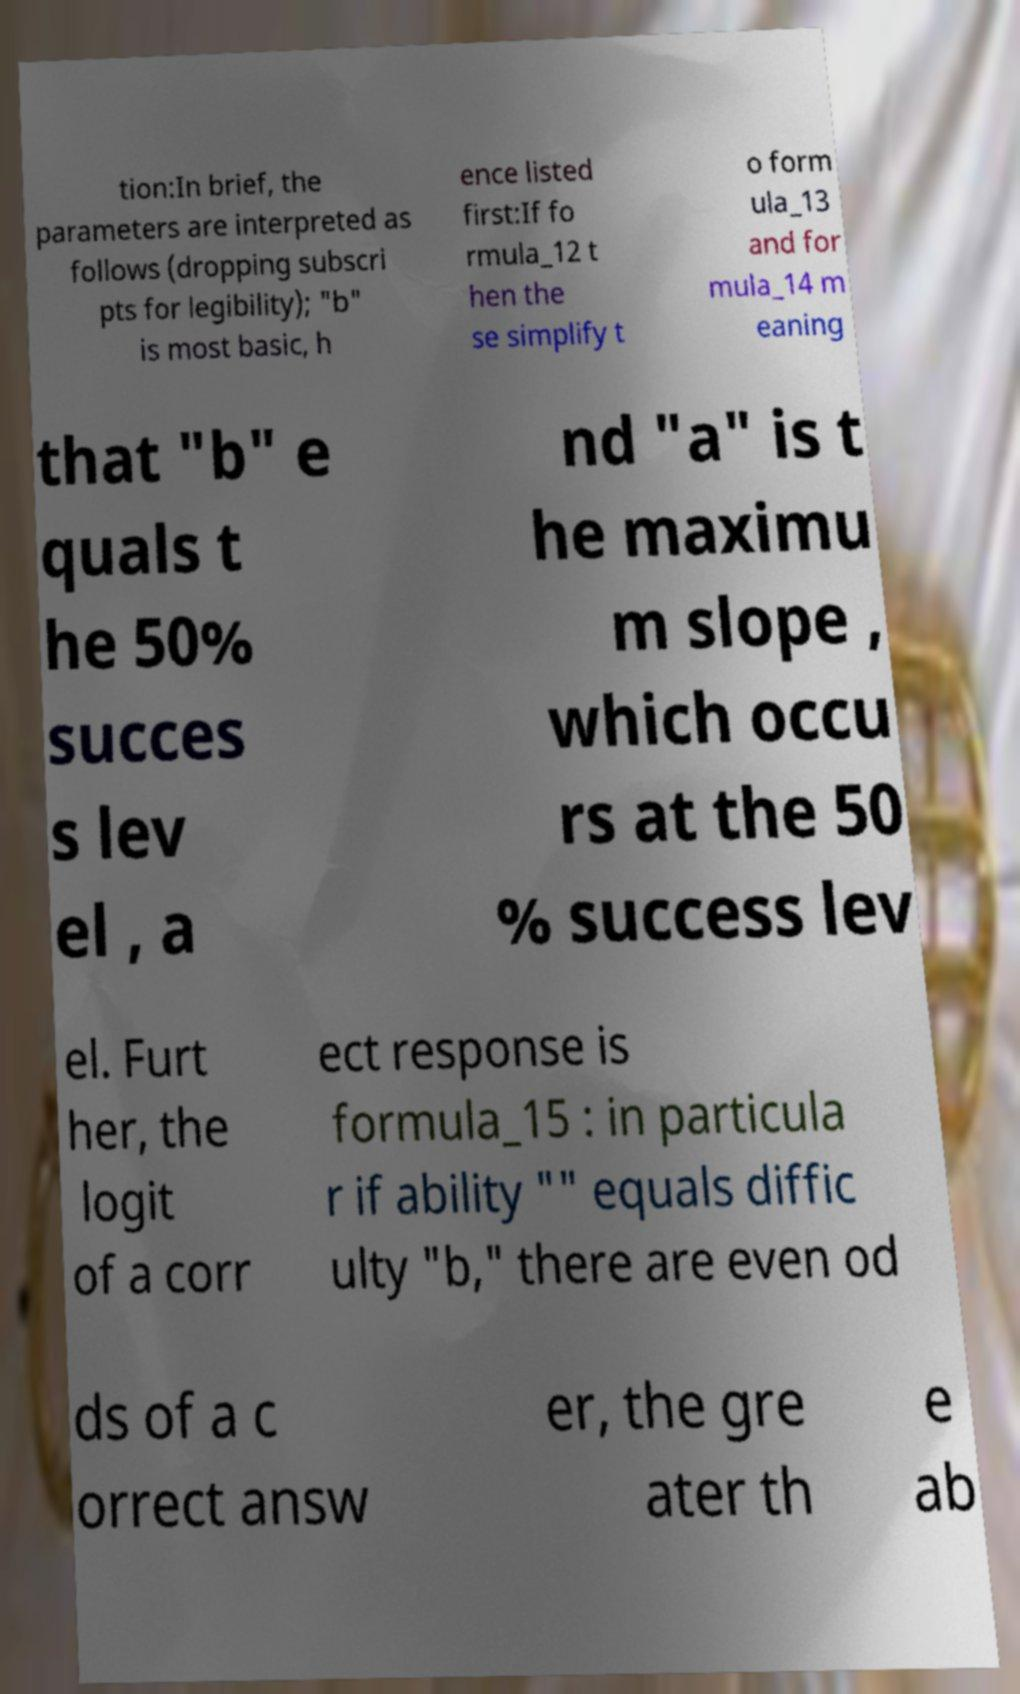Can you accurately transcribe the text from the provided image for me? tion:In brief, the parameters are interpreted as follows (dropping subscri pts for legibility); "b" is most basic, h ence listed first:If fo rmula_12 t hen the se simplify t o form ula_13 and for mula_14 m eaning that "b" e quals t he 50% succes s lev el , a nd "a" is t he maximu m slope , which occu rs at the 50 % success lev el. Furt her, the logit of a corr ect response is formula_15 : in particula r if ability "" equals diffic ulty "b," there are even od ds of a c orrect answ er, the gre ater th e ab 